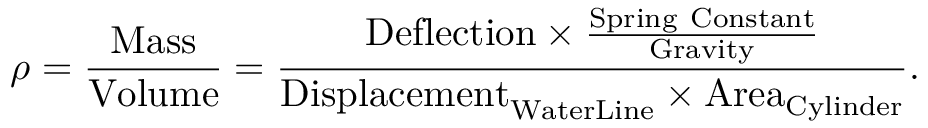<formula> <loc_0><loc_0><loc_500><loc_500>\rho = { \frac { M a s s } { V o l u m e } } = { \frac { { D e f l e c t i o n } \times { \frac { S p r i n g C o n s t a n t } { G r a v i t y } } } { { D i s p l a c e m e n t } _ { W a t e r L i n e } \times { A r e a } _ { C y l i n d e r } } } .</formula> 